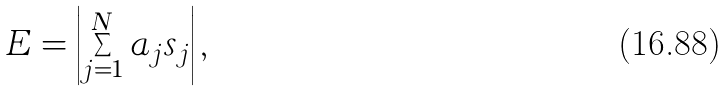<formula> <loc_0><loc_0><loc_500><loc_500>E = \left | \sum _ { j = 1 } ^ { N } a _ { j } s _ { j } \right | ,</formula> 